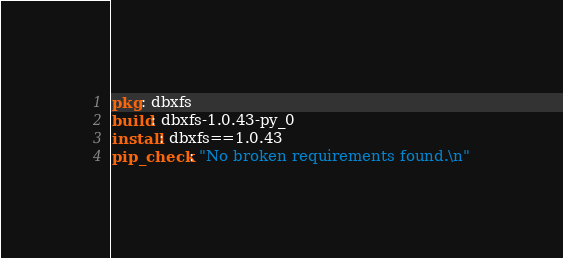<code> <loc_0><loc_0><loc_500><loc_500><_YAML_>pkg: dbxfs
build: dbxfs-1.0.43-py_0
install: dbxfs==1.0.43
pip_check: "No broken requirements found.\n"
</code> 